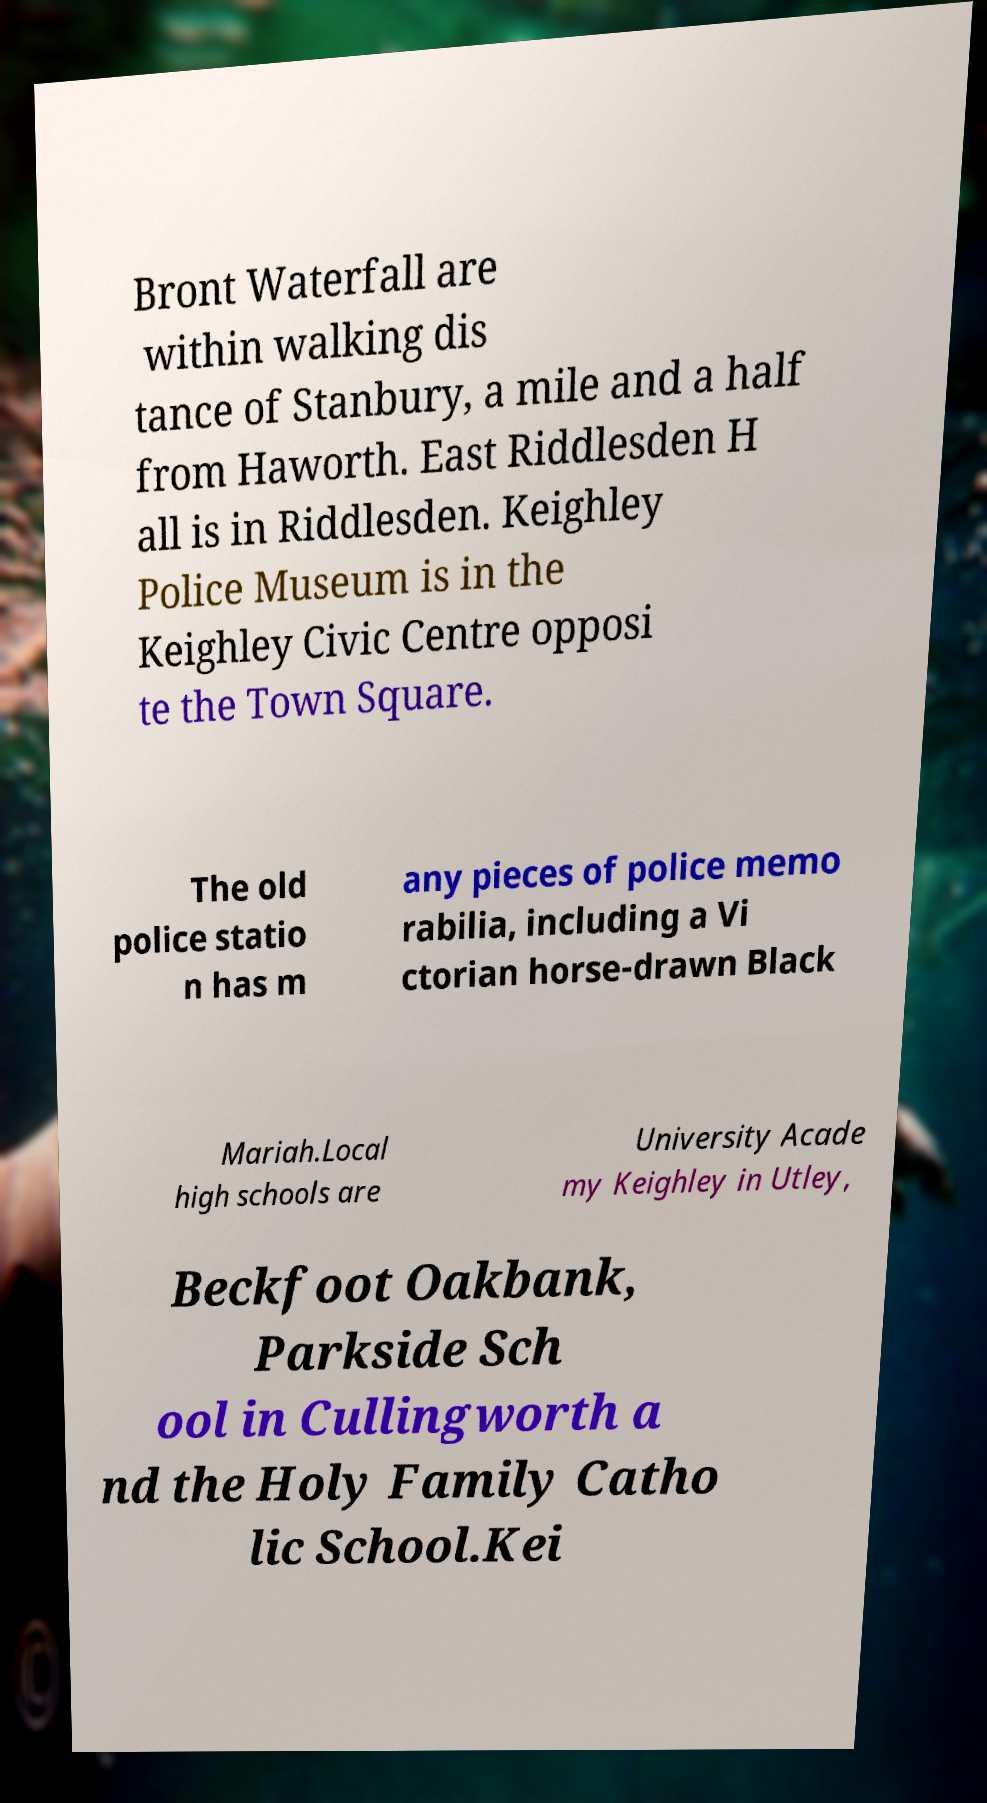Can you read and provide the text displayed in the image?This photo seems to have some interesting text. Can you extract and type it out for me? Bront Waterfall are within walking dis tance of Stanbury, a mile and a half from Haworth. East Riddlesden H all is in Riddlesden. Keighley Police Museum is in the Keighley Civic Centre opposi te the Town Square. The old police statio n has m any pieces of police memo rabilia, including a Vi ctorian horse-drawn Black Mariah.Local high schools are University Acade my Keighley in Utley, Beckfoot Oakbank, Parkside Sch ool in Cullingworth a nd the Holy Family Catho lic School.Kei 